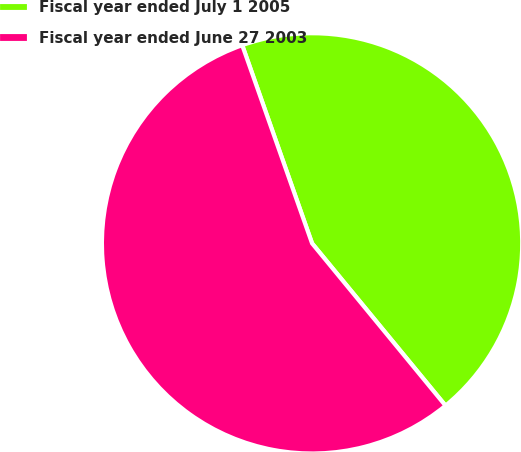Convert chart. <chart><loc_0><loc_0><loc_500><loc_500><pie_chart><fcel>Fiscal year ended July 1 2005<fcel>Fiscal year ended June 27 2003<nl><fcel>44.44%<fcel>55.56%<nl></chart> 